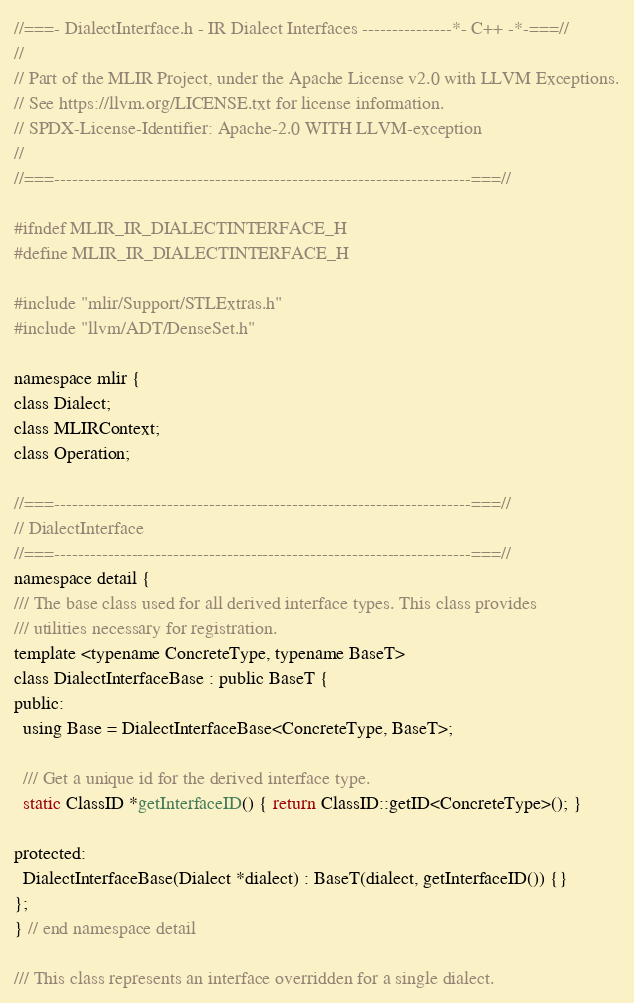Convert code to text. <code><loc_0><loc_0><loc_500><loc_500><_C_>//===- DialectInterface.h - IR Dialect Interfaces ---------------*- C++ -*-===//
//
// Part of the MLIR Project, under the Apache License v2.0 with LLVM Exceptions.
// See https://llvm.org/LICENSE.txt for license information.
// SPDX-License-Identifier: Apache-2.0 WITH LLVM-exception
//
//===----------------------------------------------------------------------===//

#ifndef MLIR_IR_DIALECTINTERFACE_H
#define MLIR_IR_DIALECTINTERFACE_H

#include "mlir/Support/STLExtras.h"
#include "llvm/ADT/DenseSet.h"

namespace mlir {
class Dialect;
class MLIRContext;
class Operation;

//===----------------------------------------------------------------------===//
// DialectInterface
//===----------------------------------------------------------------------===//
namespace detail {
/// The base class used for all derived interface types. This class provides
/// utilities necessary for registration.
template <typename ConcreteType, typename BaseT>
class DialectInterfaceBase : public BaseT {
public:
  using Base = DialectInterfaceBase<ConcreteType, BaseT>;

  /// Get a unique id for the derived interface type.
  static ClassID *getInterfaceID() { return ClassID::getID<ConcreteType>(); }

protected:
  DialectInterfaceBase(Dialect *dialect) : BaseT(dialect, getInterfaceID()) {}
};
} // end namespace detail

/// This class represents an interface overridden for a single dialect.</code> 